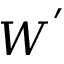<formula> <loc_0><loc_0><loc_500><loc_500>W ^ { ^ { \prime } }</formula> 